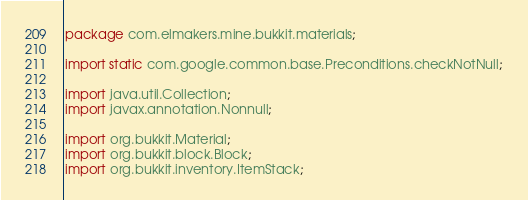<code> <loc_0><loc_0><loc_500><loc_500><_Java_>package com.elmakers.mine.bukkit.materials;

import static com.google.common.base.Preconditions.checkNotNull;

import java.util.Collection;
import javax.annotation.Nonnull;

import org.bukkit.Material;
import org.bukkit.block.Block;
import org.bukkit.inventory.ItemStack;
</code> 